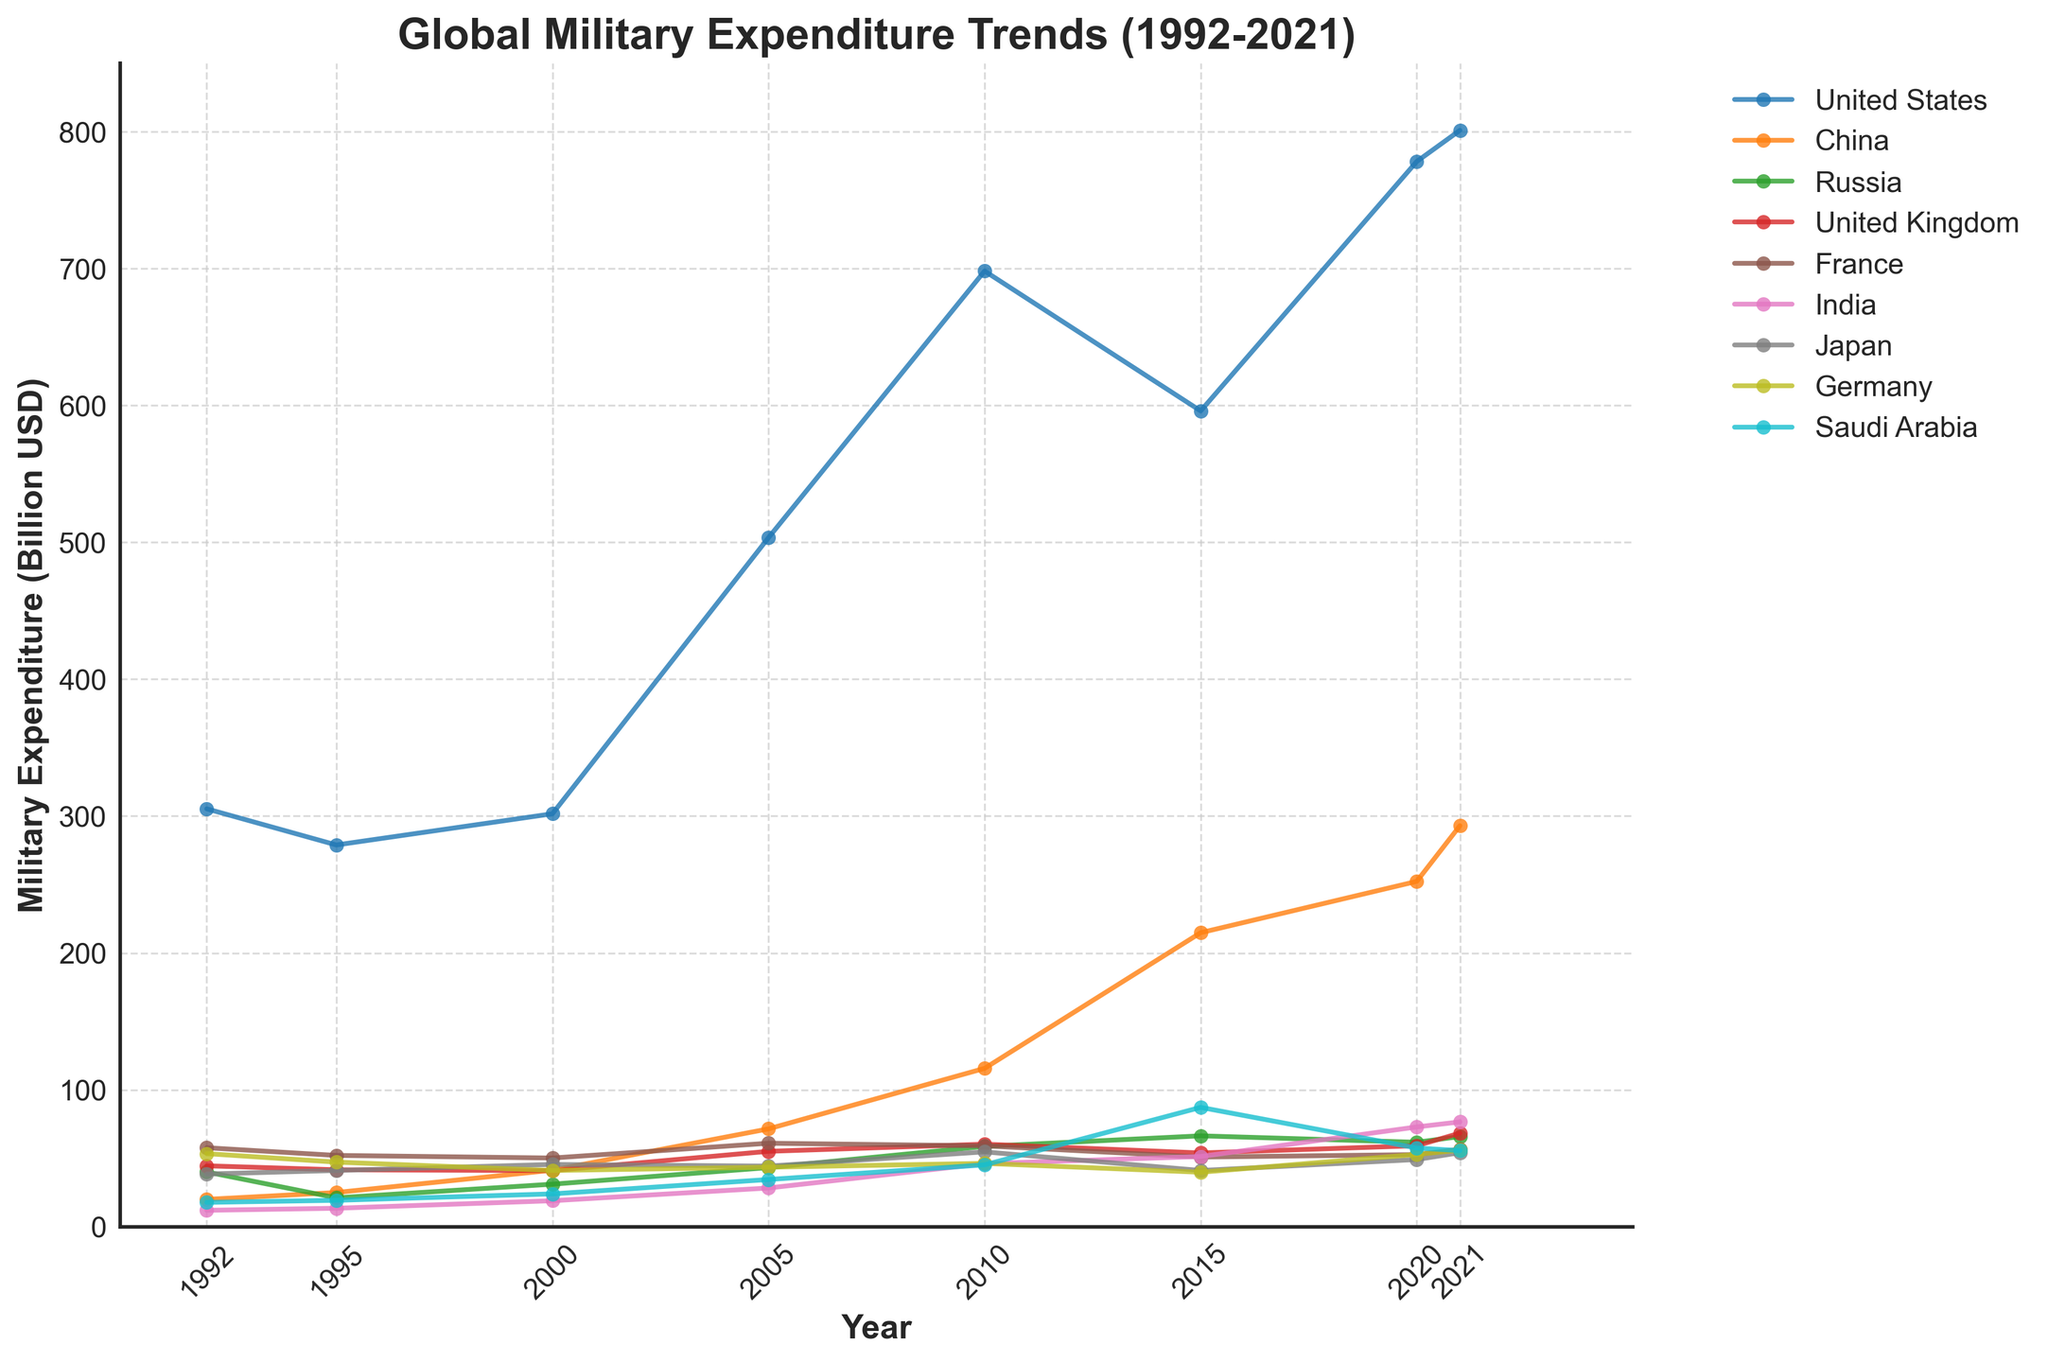What's the overall trend in military expenditure for the United States from 1992 to 2021? To identify the trend, look at the trajectory of the line representing the United States. The data points indicate a general increase, with some fluctuations. Starting at 305.3 billion USD in 1992, peaking around 2010 with 698.2 billion USD, dipping slightly around 2015, and increasing again to 801.0 billion USD in 2021.
Answer: Increasing trend Which country showed the most significant increase in military expenditure from 1992 to 2021? Examining the lines, the one with the steepest positive slope indicates the most significant increase. China's line starts at 20.0 billion USD in 1992 and rises significantly to 293.0 billion USD by 2021.
Answer: China In 2020, how did the military expenditure of India compare to that of Saudi Arabia? Look at the data points for India and Saudi Arabia in 2020. India's expenditure is 72.9 billion USD, and Saudi Arabia's is 57.5 billion USD. India spent more.
Answer: India spent more What was the difference in military expenditure between Russia and France in 2000? Look at the figures for both countries in the year 2000. Russia's expenditure was 31.1 billion USD, and France's was 50.2 billion USD. Subtract Russia's expenditure from France's to find the difference (50.2 - 31.1 = 19.1 billion USD).
Answer: 19.1 billion USD Which country had the highest military expenditure in 2015, and what was the expenditure? Identify the highest point on the graph in 2015. The United States had the highest expenditure at 596.0 billion USD.
Answer: The United States, 596.0 billion USD Compare the military expenditures of Japan and Germany in 1995. Which country spent more, and what was the difference? Find the data points for Japan and Germany in 1995. Japan's expenditure was 41.1 billion USD, and Germany's was 47.2 billion USD. Germany spent more. The difference is 47.2 - 41.1 = 6.1 billion USD.
Answer: Germany, 6.1 billion USD How did France's military expenditure change from 1995 to 2005? Look at France's data points for 1995 and 2005. The expenditure increased from 52.1 billion USD in 1995 to 61.0 billion USD in 2005.
Answer: Increased by 8.9 billion USD What is the trend of Russia's military expenditure between 1992 and 2021? Observe Russia's line. It starts at 40.0 billion USD in 1992, fluctuates slightly with a peak around 2015 at 66.4 billion USD, and then slightly declines to 65.9 billion USD by 2021.
Answer: Fluctuating with a slight increase Which countries surpassed the 100-billion USD mark in military expenditure in 2010? Identify the countries with data points over 100 billion USD in 2010. Both the United States (698.2) and China (115.7) surpass this mark.
Answer: The United States and China Determine the compound annual growth rate (CAGR) of India's military expenditure from 1992 to 2021. The formula for CAGR is (End Value/Start Value)^(1/Number of Years) - 1. For India, the start value in 1992 is 12.0 billion USD, and the end value in 2021 is 76.6 billion USD. The number of years is 2021-1992 = 29 years. Calculating (76.6/12.0)^(1/29) - 1 results in approximately 6.6%.
Answer: Approximately 6.6% 